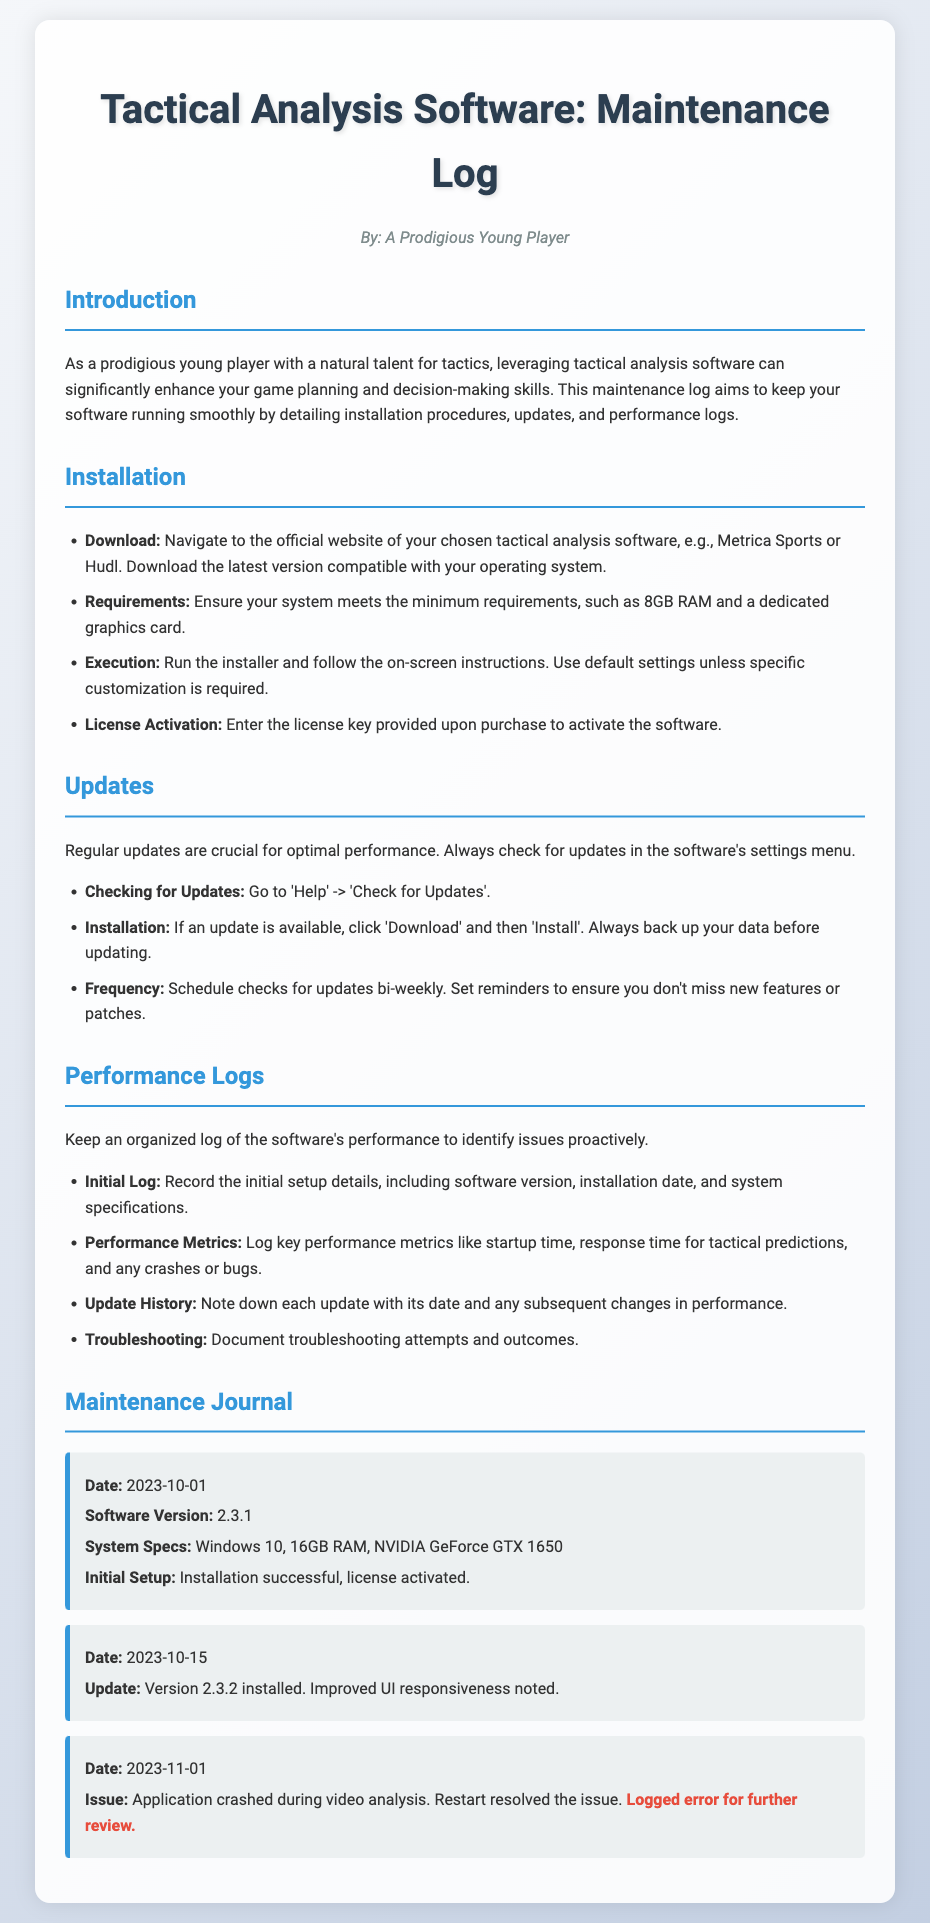what is the software version noted on 2023-10-01? The software version listed for that date is found in the performance log entry.
Answer: 2.3.1 what was noted about the UI in the update on 2023-10-15? The update entry specifies a change in performance after the installation of version 2.3.2.
Answer: Improved UI responsiveness how much RAM is required for installation? The installation requirements mention the necessary RAM for the software.
Answer: 8GB RAM what was the issue documented on 2023-11-01? The performance log entry describes a problem that occurred during use.
Answer: Application crashed during video analysis how often should checks for updates be scheduled? The updates section provides a suggested schedule for checking for updates.
Answer: Bi-weekly which system specification was included in the initial log on 2023-10-01? The initial setup details include specifications that were recorded after installation.
Answer: Windows 10, 16GB RAM, NVIDIA GeForce GTX 1650 when was version 2.3.2 installed? The date of the update for version 2.3.2 is included in the logs.
Answer: 2023-10-15 what should be done before installing an update? The maintenance log outlines a precaution to take before updating.
Answer: Back up your data 